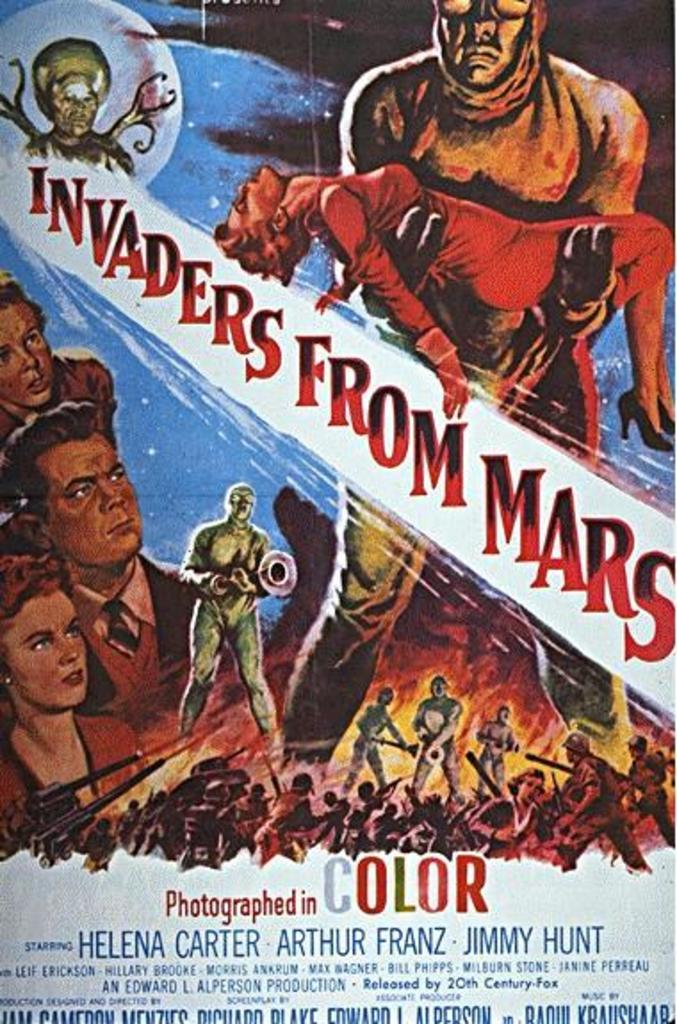<image>
Render a clear and concise summary of the photo. A movie poster advertises the film "Invaders From Mars." 